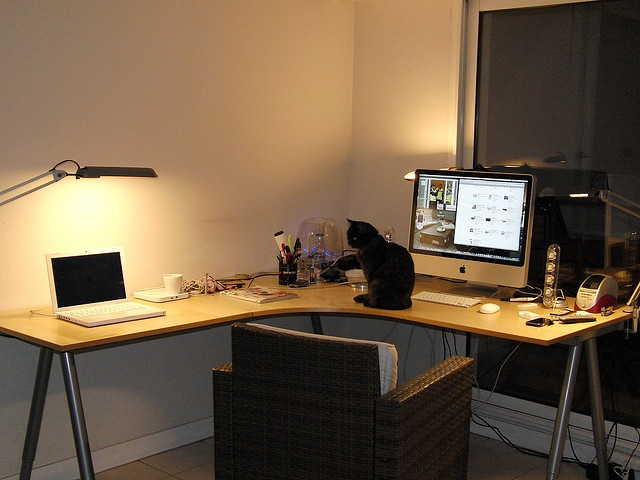Describe the objects in this image and their specific colors. I can see chair in gray, black, and maroon tones, tv in gray, white, black, and darkgray tones, laptop in gray, black, khaki, lightyellow, and tan tones, cat in gray, black, olive, and maroon tones, and book in gray, brown, and tan tones in this image. 